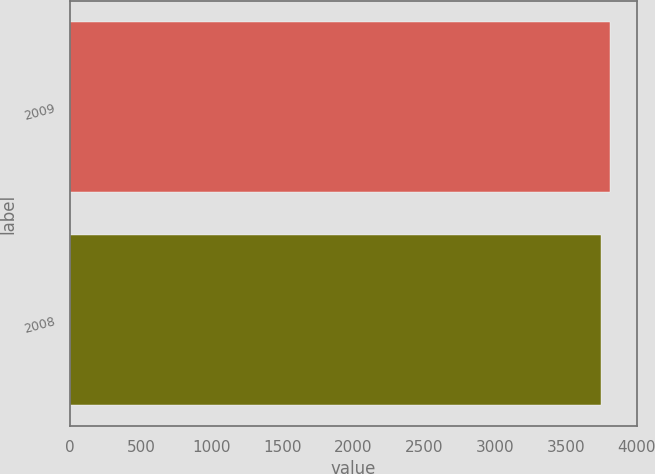Convert chart to OTSL. <chart><loc_0><loc_0><loc_500><loc_500><bar_chart><fcel>2009<fcel>2008<nl><fcel>3810<fcel>3746<nl></chart> 